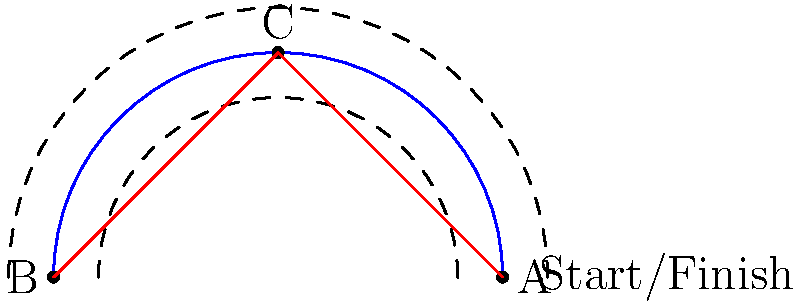A circular running track has an outer radius of 120 meters and an inner radius of 80 meters. You want to run from point A to point B in the most efficient manner. Is it faster to run along the curved path of the track or to cut across the field in a straight line? If cutting across is faster, by how many meters is the straight path shorter than the curved path? (Use $\pi \approx 3.14$ for calculations) Let's approach this step-by-step:

1) First, we need to calculate the length of the curved path:
   - The curved path is a semicircle
   - The radius of the center line of the track is $(120 + 80) / 2 = 100$ meters
   - Length of semicircle = $\pi r = \pi \times 100 \approx 314$ meters

2) Now, let's calculate the length of the straight path:
   - The straight path forms the diameter of the circle
   - Diameter = $2 \times 100 = 200$ meters

3) Compare the two paths:
   - Curved path: approximately 314 meters
   - Straight path: 200 meters

4) Calculate the difference:
   $314 - 200 = 114$ meters

Therefore, the straight path is shorter by approximately 114 meters.

This problem demonstrates the practical application of geometry in athletic strategy. As an athlete, understanding these concepts can help you optimize your performance in track events.
Answer: The straight path is faster, shorter by approximately 114 meters. 